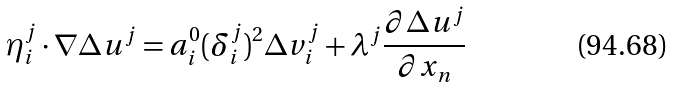<formula> <loc_0><loc_0><loc_500><loc_500>\eta ^ { j } _ { i } \cdot \nabla \Delta u ^ { j } = a ^ { 0 } _ { i } ( \delta ^ { j } _ { i } ) ^ { 2 } \Delta v ^ { j } _ { i } + \lambda ^ { j } \frac { \partial \Delta u ^ { j } } { \partial x _ { n } }</formula> 